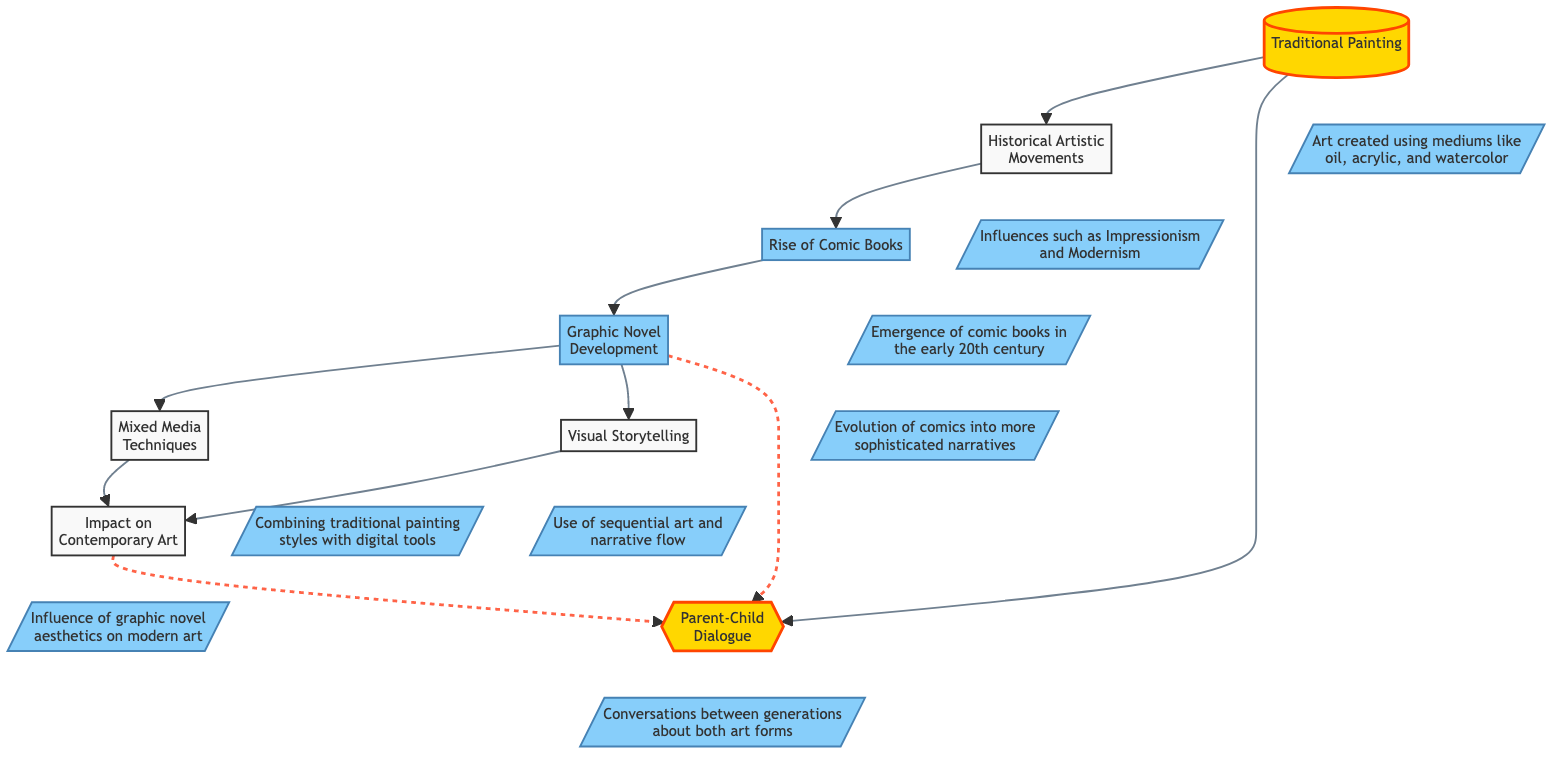What is the starting point of the flow chart? The flow chart begins with "Traditional Painting," which is the first node in the diagram.
Answer: Traditional Painting How many main elements are present in the diagram? Counting the nodes in the flow chart, there are a total of eight main elements shown.
Answer: 8 What is the relationship between "Graphic Novel Development" and "Mixed Media Techniques"? "Graphic Novel Development" leads directly to "Mixed Media Techniques," indicating that the former influences or introduces the latter.
Answer: leads to What concept follows "Rise of Comic Books"? The concept that follows "Rise of Comic Books" in the flow chart is "Graphic Novel Development."
Answer: Graphic Novel Development Which two elements connect to "Parent-Child Dialogue"? Both "Traditional Painting" and "Graphic Novel Development" connect to "Parent-Child Dialogue," showing a relationship between these forms and the conversations about art.
Answer: Traditional Painting, Graphic Novel Development What does "Visual Storytelling" influence in the diagram? "Visual Storytelling" influences "Impact on Contemporary Art," indicating that storytelling techniques in graphic novels affect modern art practices.
Answer: Impact on Contemporary Art How does "Historical Artistic Movements" relate to "Rise of Comic Books"? "Historical Artistic Movements" precedes and leads to "Rise of Comic Books," suggesting that past art movements have influenced the emergence of comic books.
Answer: leads to What artistic techniques are mentioned in the flow chart? The techniques mentioned in the flow chart include "Mixed Media Techniques," which combines traditional styles with digital tools.
Answer: Mixed Media Techniques 